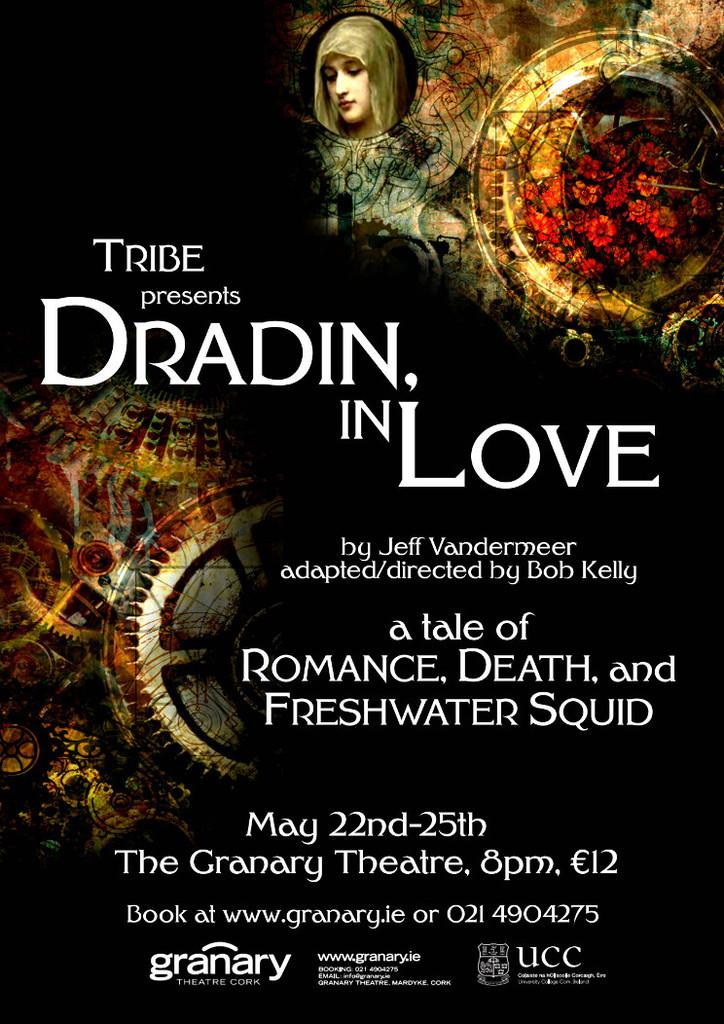Where is this play playing at?
Provide a short and direct response. The granary theatre. What time is the event?
Your answer should be compact. 8 pm. 